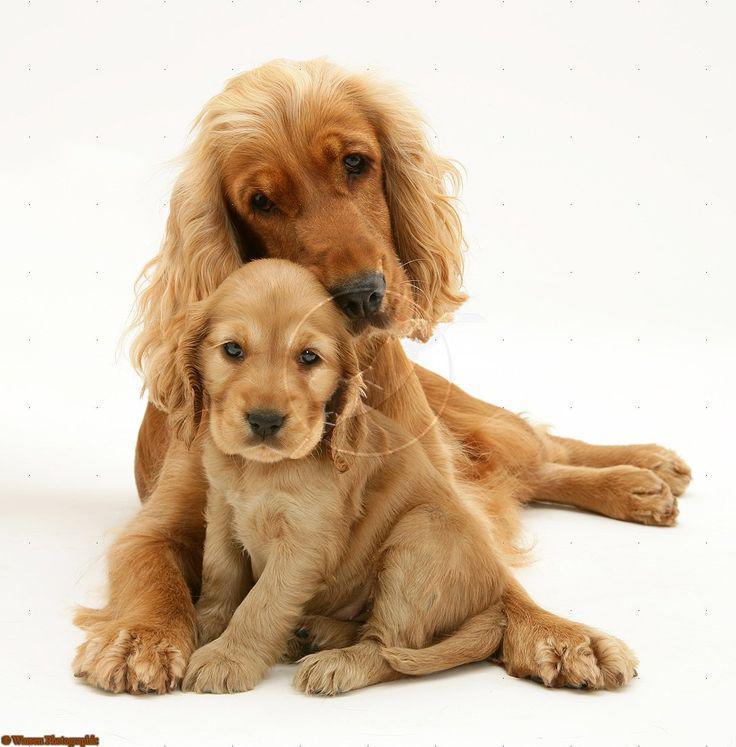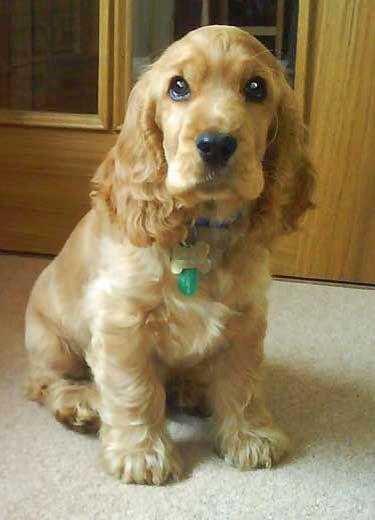The first image is the image on the left, the second image is the image on the right. Assess this claim about the two images: "There's at least two dogs in the right image.". Correct or not? Answer yes or no. No. 